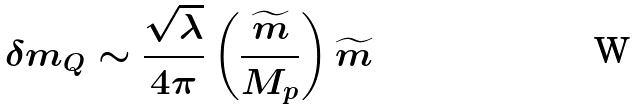<formula> <loc_0><loc_0><loc_500><loc_500>\delta m _ { Q } \sim \frac { \sqrt { \lambda } } { 4 \pi } \left ( \frac { \widetilde { m } } { M _ { p } } \right ) \widetilde { m }</formula> 